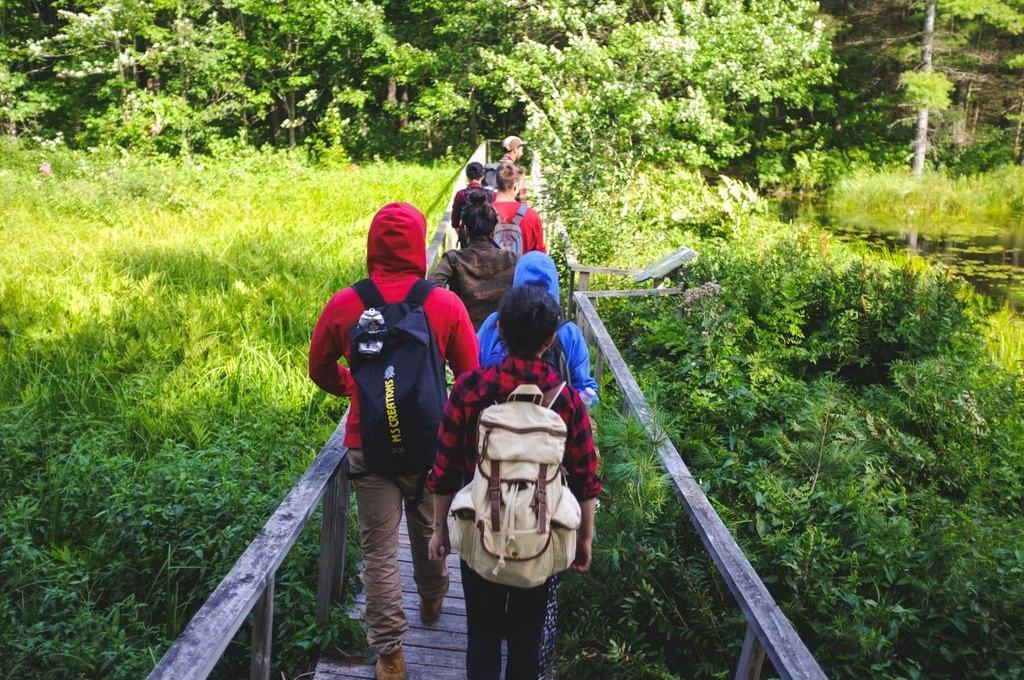In one or two sentences, can you explain what this image depicts? There are persons and these persons are worn bags and we can see plants. On the background we can see trees. 